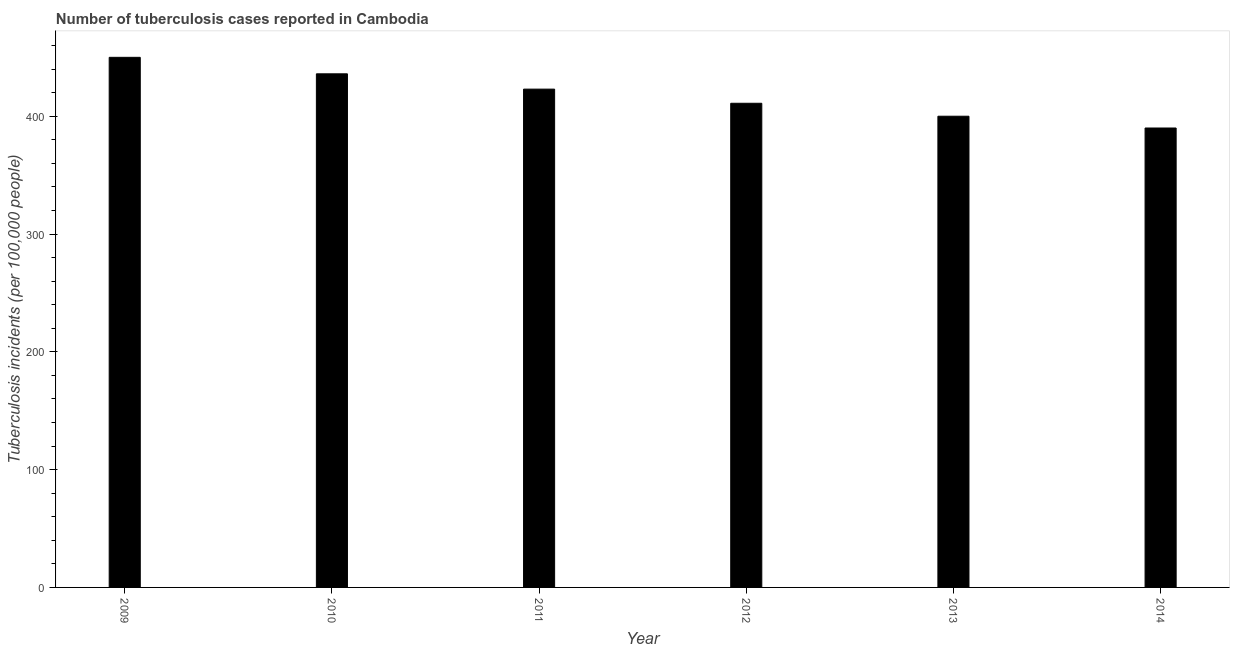Does the graph contain grids?
Make the answer very short. No. What is the title of the graph?
Your answer should be compact. Number of tuberculosis cases reported in Cambodia. What is the label or title of the Y-axis?
Make the answer very short. Tuberculosis incidents (per 100,0 people). What is the number of tuberculosis incidents in 2010?
Provide a succinct answer. 436. Across all years, what is the maximum number of tuberculosis incidents?
Offer a very short reply. 450. Across all years, what is the minimum number of tuberculosis incidents?
Ensure brevity in your answer.  390. In which year was the number of tuberculosis incidents maximum?
Provide a short and direct response. 2009. What is the sum of the number of tuberculosis incidents?
Offer a terse response. 2510. What is the difference between the number of tuberculosis incidents in 2010 and 2014?
Give a very brief answer. 46. What is the average number of tuberculosis incidents per year?
Your response must be concise. 418. What is the median number of tuberculosis incidents?
Provide a succinct answer. 417. What is the ratio of the number of tuberculosis incidents in 2010 to that in 2014?
Keep it short and to the point. 1.12. Is the number of tuberculosis incidents in 2009 less than that in 2011?
Your answer should be very brief. No. What is the difference between the highest and the second highest number of tuberculosis incidents?
Offer a terse response. 14. What is the difference between the highest and the lowest number of tuberculosis incidents?
Make the answer very short. 60. How many bars are there?
Make the answer very short. 6. Are all the bars in the graph horizontal?
Your answer should be compact. No. Are the values on the major ticks of Y-axis written in scientific E-notation?
Your answer should be very brief. No. What is the Tuberculosis incidents (per 100,000 people) of 2009?
Your answer should be compact. 450. What is the Tuberculosis incidents (per 100,000 people) of 2010?
Your answer should be compact. 436. What is the Tuberculosis incidents (per 100,000 people) in 2011?
Offer a terse response. 423. What is the Tuberculosis incidents (per 100,000 people) in 2012?
Offer a very short reply. 411. What is the Tuberculosis incidents (per 100,000 people) of 2014?
Your answer should be compact. 390. What is the difference between the Tuberculosis incidents (per 100,000 people) in 2009 and 2012?
Give a very brief answer. 39. What is the difference between the Tuberculosis incidents (per 100,000 people) in 2009 and 2013?
Keep it short and to the point. 50. What is the difference between the Tuberculosis incidents (per 100,000 people) in 2010 and 2011?
Offer a very short reply. 13. What is the difference between the Tuberculosis incidents (per 100,000 people) in 2010 and 2013?
Provide a short and direct response. 36. What is the difference between the Tuberculosis incidents (per 100,000 people) in 2010 and 2014?
Offer a very short reply. 46. What is the difference between the Tuberculosis incidents (per 100,000 people) in 2011 and 2012?
Make the answer very short. 12. What is the difference between the Tuberculosis incidents (per 100,000 people) in 2011 and 2013?
Your response must be concise. 23. What is the difference between the Tuberculosis incidents (per 100,000 people) in 2011 and 2014?
Your answer should be very brief. 33. What is the difference between the Tuberculosis incidents (per 100,000 people) in 2012 and 2014?
Ensure brevity in your answer.  21. What is the ratio of the Tuberculosis incidents (per 100,000 people) in 2009 to that in 2010?
Your answer should be very brief. 1.03. What is the ratio of the Tuberculosis incidents (per 100,000 people) in 2009 to that in 2011?
Your response must be concise. 1.06. What is the ratio of the Tuberculosis incidents (per 100,000 people) in 2009 to that in 2012?
Provide a succinct answer. 1.09. What is the ratio of the Tuberculosis incidents (per 100,000 people) in 2009 to that in 2013?
Ensure brevity in your answer.  1.12. What is the ratio of the Tuberculosis incidents (per 100,000 people) in 2009 to that in 2014?
Your response must be concise. 1.15. What is the ratio of the Tuberculosis incidents (per 100,000 people) in 2010 to that in 2011?
Ensure brevity in your answer.  1.03. What is the ratio of the Tuberculosis incidents (per 100,000 people) in 2010 to that in 2012?
Your response must be concise. 1.06. What is the ratio of the Tuberculosis incidents (per 100,000 people) in 2010 to that in 2013?
Provide a succinct answer. 1.09. What is the ratio of the Tuberculosis incidents (per 100,000 people) in 2010 to that in 2014?
Your response must be concise. 1.12. What is the ratio of the Tuberculosis incidents (per 100,000 people) in 2011 to that in 2012?
Your answer should be very brief. 1.03. What is the ratio of the Tuberculosis incidents (per 100,000 people) in 2011 to that in 2013?
Provide a succinct answer. 1.06. What is the ratio of the Tuberculosis incidents (per 100,000 people) in 2011 to that in 2014?
Make the answer very short. 1.08. What is the ratio of the Tuberculosis incidents (per 100,000 people) in 2012 to that in 2013?
Offer a terse response. 1.03. What is the ratio of the Tuberculosis incidents (per 100,000 people) in 2012 to that in 2014?
Keep it short and to the point. 1.05. 